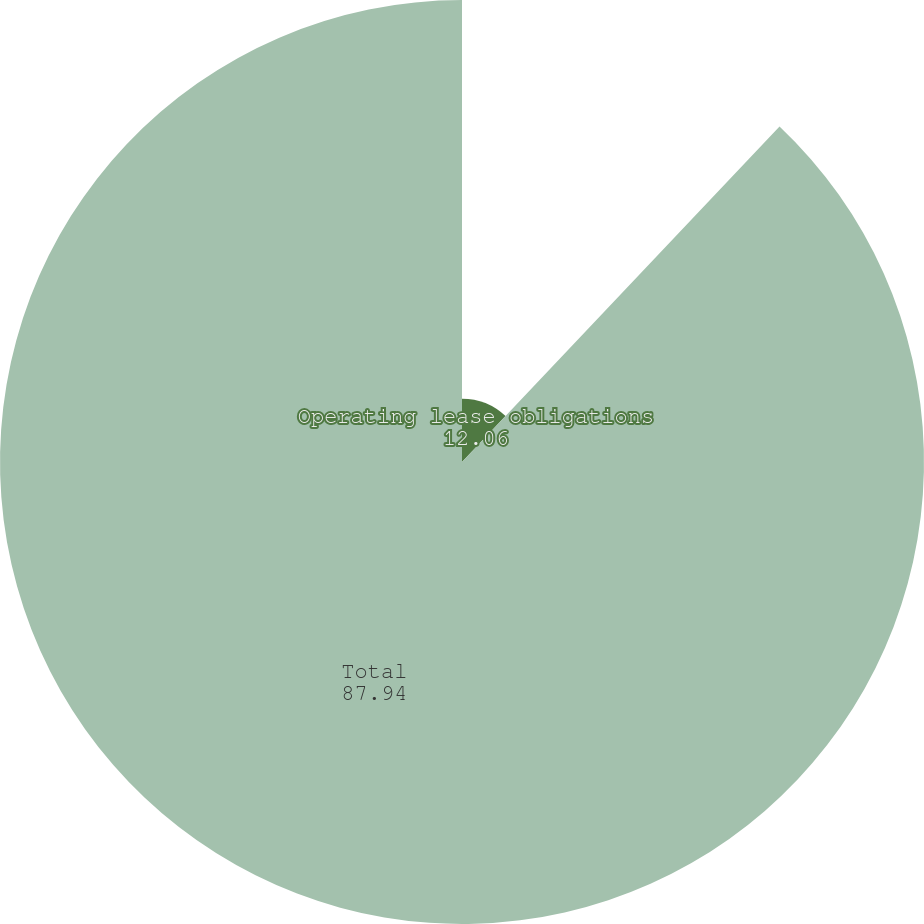<chart> <loc_0><loc_0><loc_500><loc_500><pie_chart><fcel>Operating lease obligations<fcel>Total<nl><fcel>12.06%<fcel>87.94%<nl></chart> 